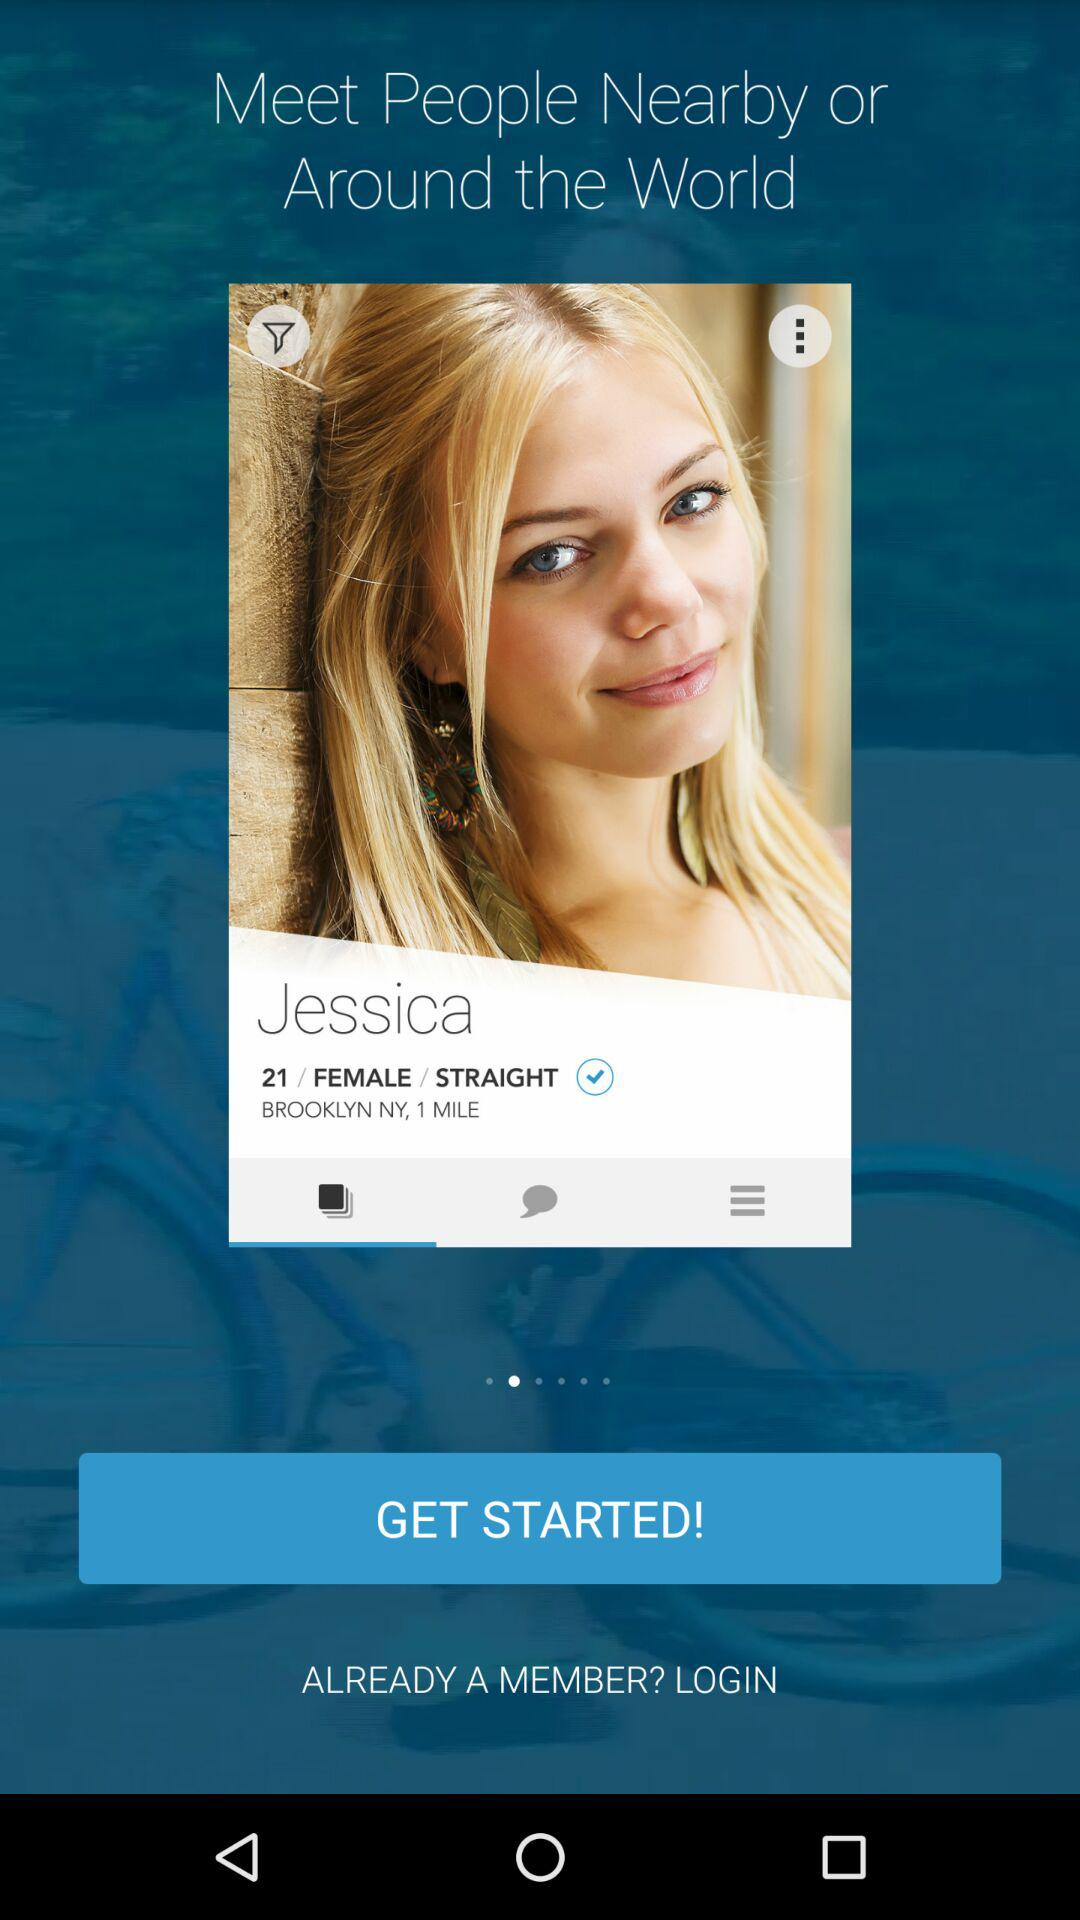What is the mentioned place? The mentioned place is Brooklyn, NY. 